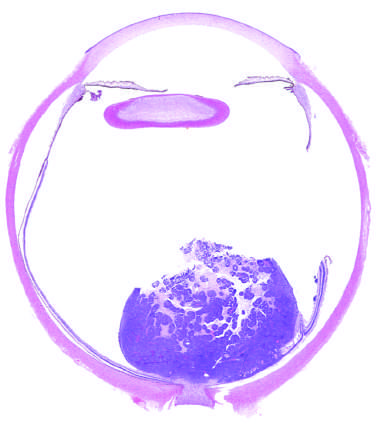what is seen abutting the optic nerve?
Answer the question using a single word or phrase. Poorly cohesive tumor in retina 